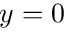Convert formula to latex. <formula><loc_0><loc_0><loc_500><loc_500>y = 0</formula> 